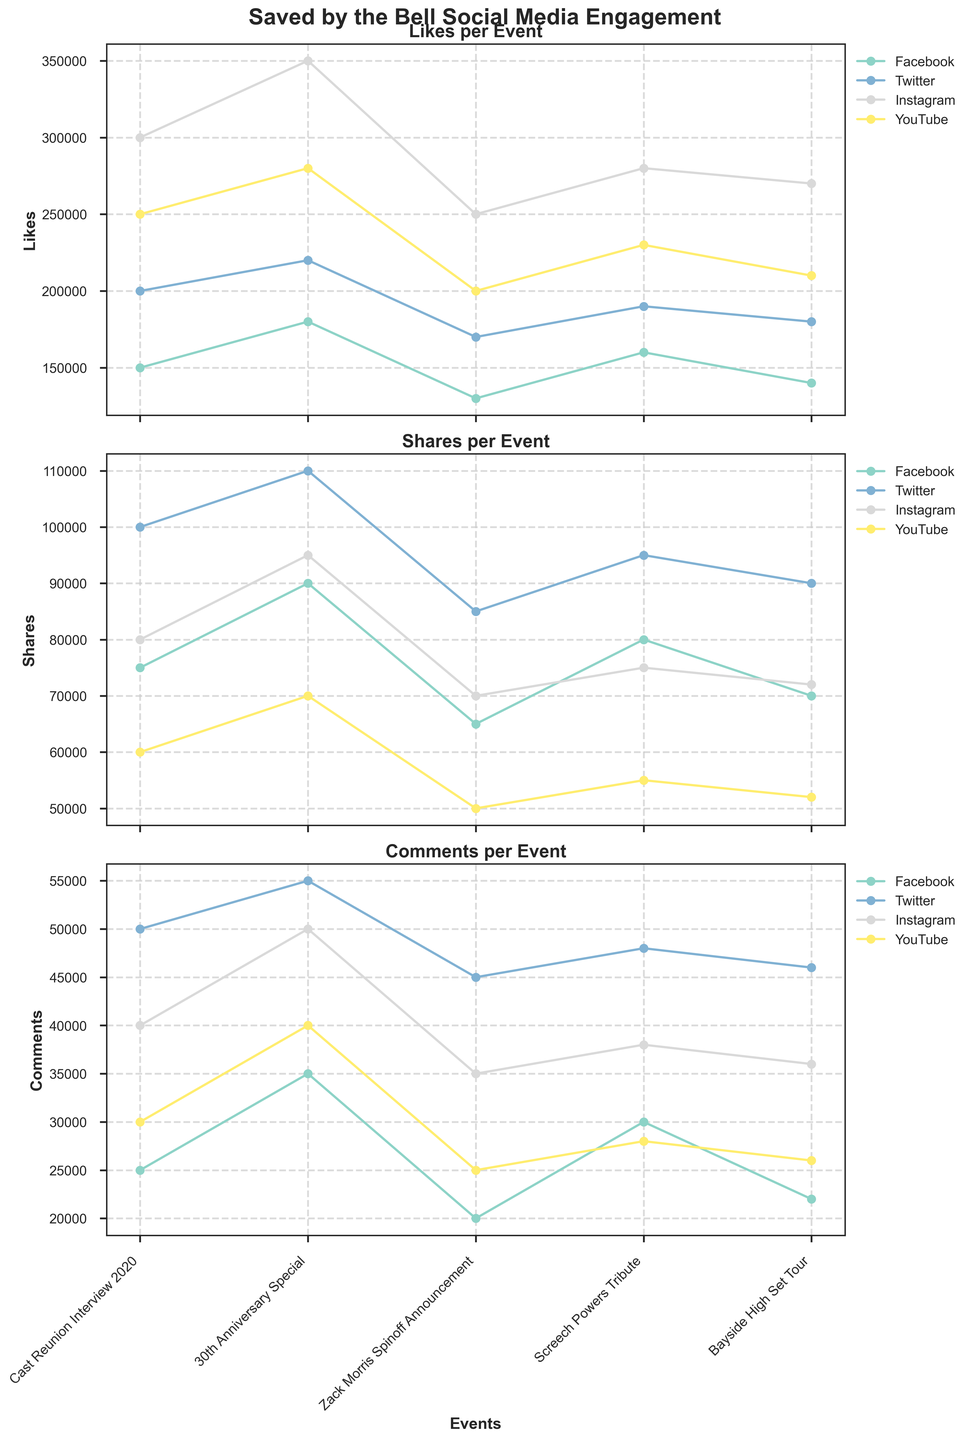Which event garnered the highest number of likes on Instagram? Look at the line representing Instagram in the Likes plot and find the peak value
Answer: 30th Anniversary Special On which platform did the Screech Powers Tribute receive the most shares? Look at the lines in the Shares plot corresponding to the Screech Powers Tribute and compare the values
Answer: Twitter Compare the comments received on Facebook for the Zack Morris Spinoff Announcement against the Bayside High Set Tour. Which event had more comments? Locate the points for Facebook in the Comments plot and compare the vertical heights for the two events
Answer: Zack Morris Spinoff Announcement Which event had the lowest number of shares on YouTube? Look at the YouTube line in the Shares plot and identify the lowest point
Answer: Zack Morris Spinoff Announcement Among all platforms, which received the highest engagement (likes + shares + comments) for the Bayside High Set Tour? Add Likes, Shares, and Comments for each platform for the Bayside High Set Tour and compare the sums
Answer: Instagram For the Cast Reunion Interview 2020, are the total comments on Twitter greater than those on Instagram and Facebook combined? Compare the sum of comments on Instagram and Facebook to the comments on Twitter for Cast Reunion Interview 2020
Answer: No Which platform saw the least engagement (likes + shares + comments) for the Cast Reunion Interview 2020? Add Likes, Shares, and Comments for each platform for the event and compare the sums
Answer: Facebook How does the number of likes on YouTube for the 30th Anniversary Special compare to the number for the Cast Reunion Interview 2020? Compare the heights of the YouTube lines for the number of likes at the two events
Answer: Likes for 30th Anniversary Special are higher Rank the events in descending order of comments on Facebook. By looking at the Comments plot for Facebook, arrange events from highest to lowest
Answer: 30th Anniversary Special, Screech Powers Tribute, Cast Reunion Interview 2020, Bayside High Set Tour, Zack Morris Spinoff Announcement Which platform had the smallest increase in shares from the Cast Reunion Interview 2020 to the 30th Anniversary Special? Calculate the difference in shares for each platform from the Cast Reunion Interview 2020 to the 30th Anniversary Special and compare
Answer: Instagram 